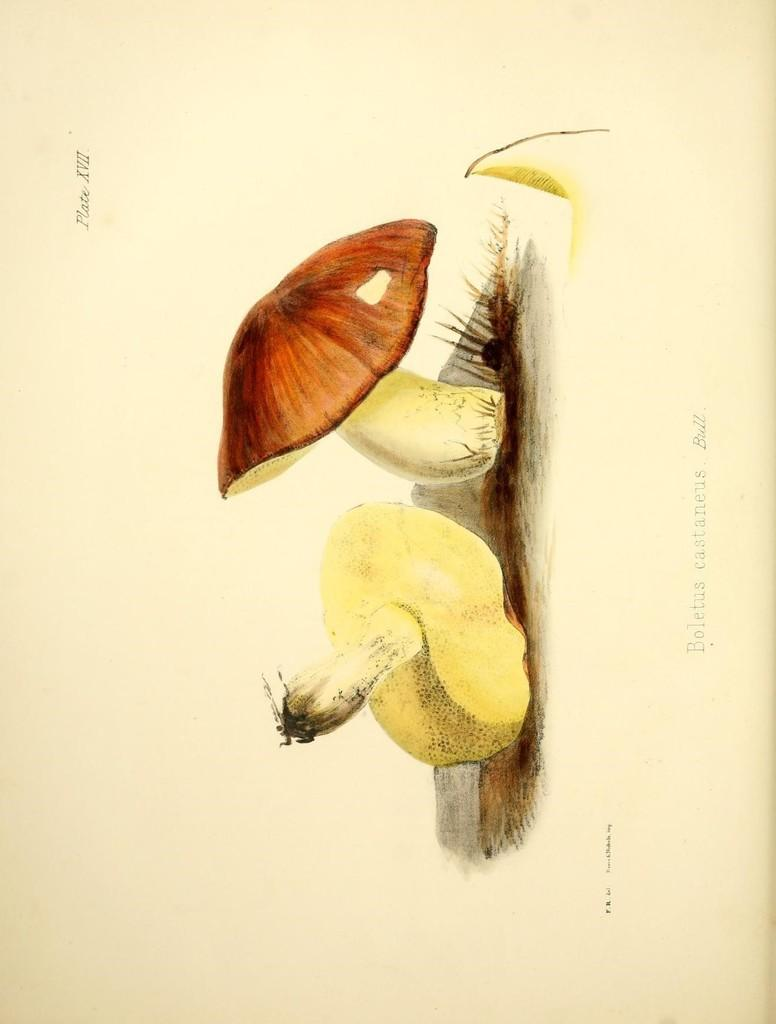What is the main subject of the image? There is a painting in the image. What is depicted in the painting? The painting depicts two mushrooms. Where are the mushrooms located in the painting? The mushrooms are on the ground. What type of acoustics can be heard in the painting? There are no sounds or acoustics present in the painting, as it is a visual representation of two mushrooms on the ground. 